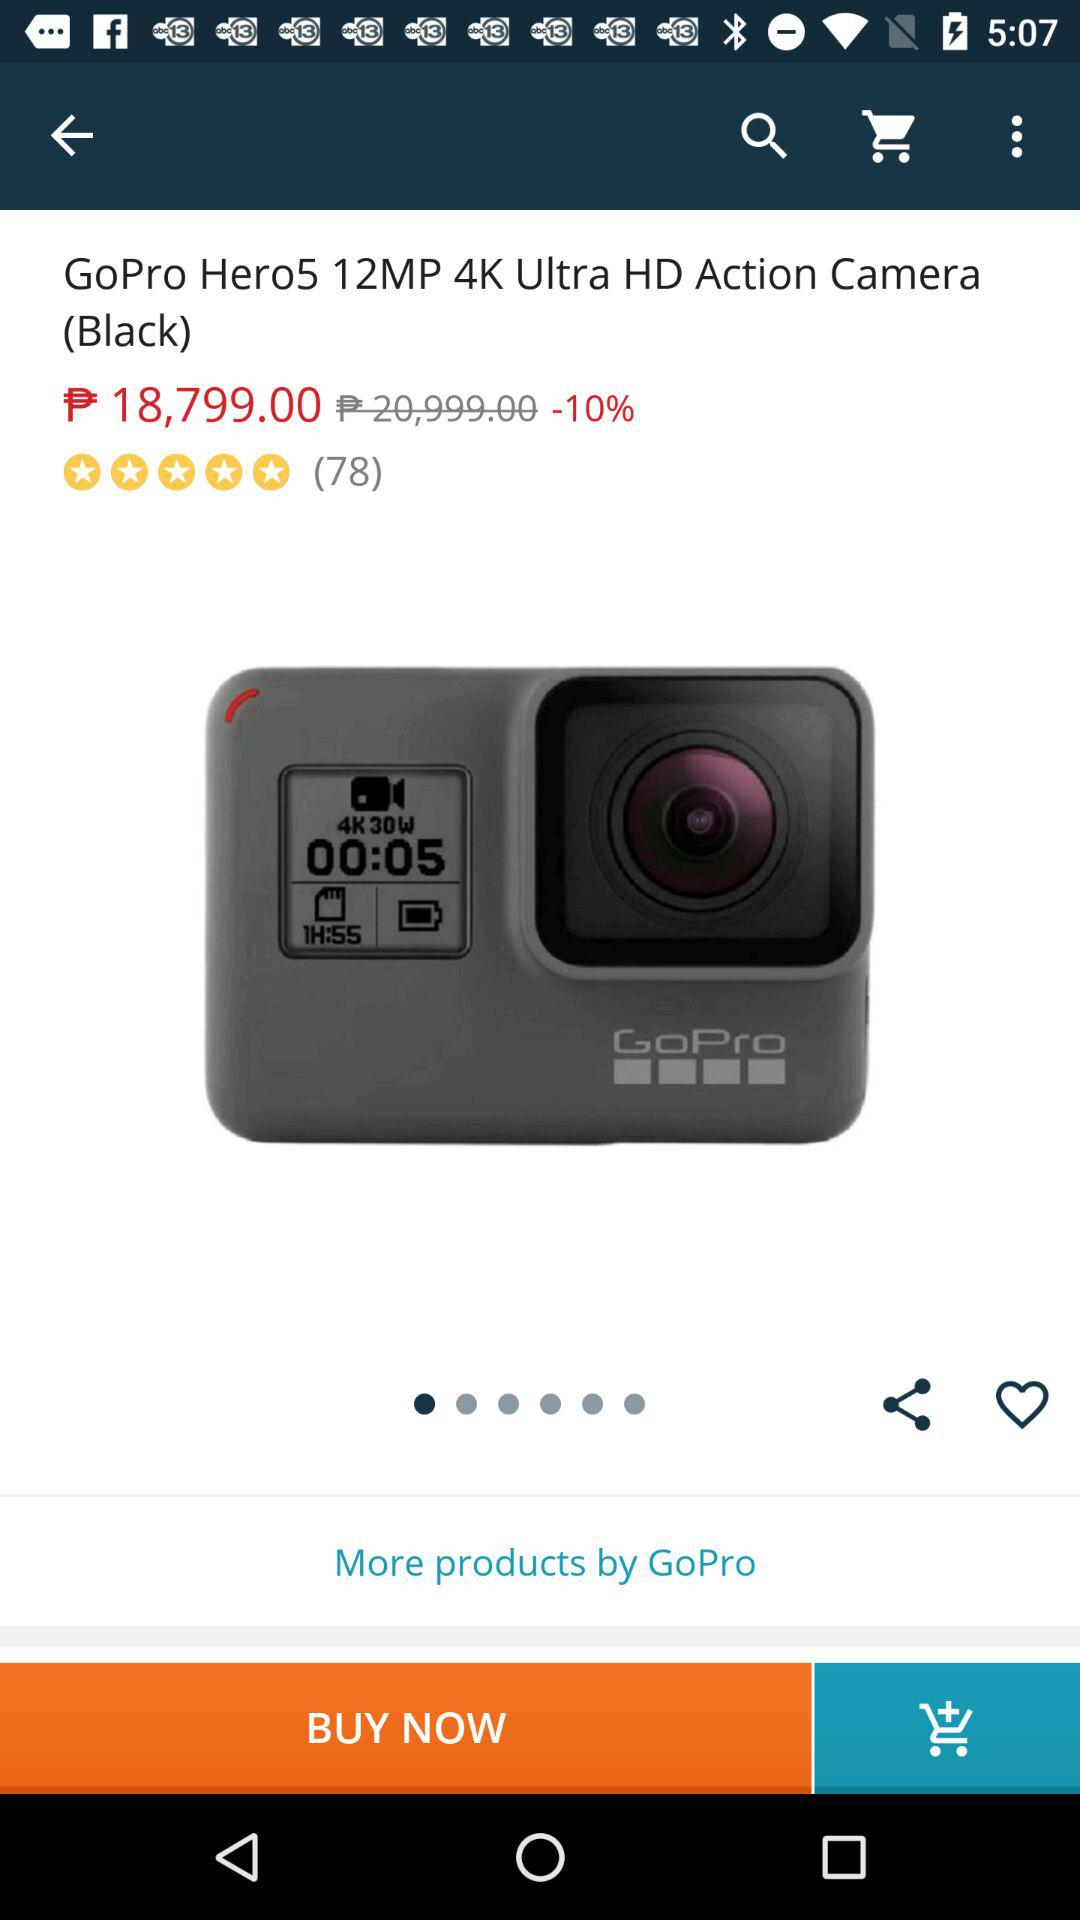What is the name of device? The name of the device is "GoPro Hero5 12MP 4K Ultra HD Action Camera (Black)". 